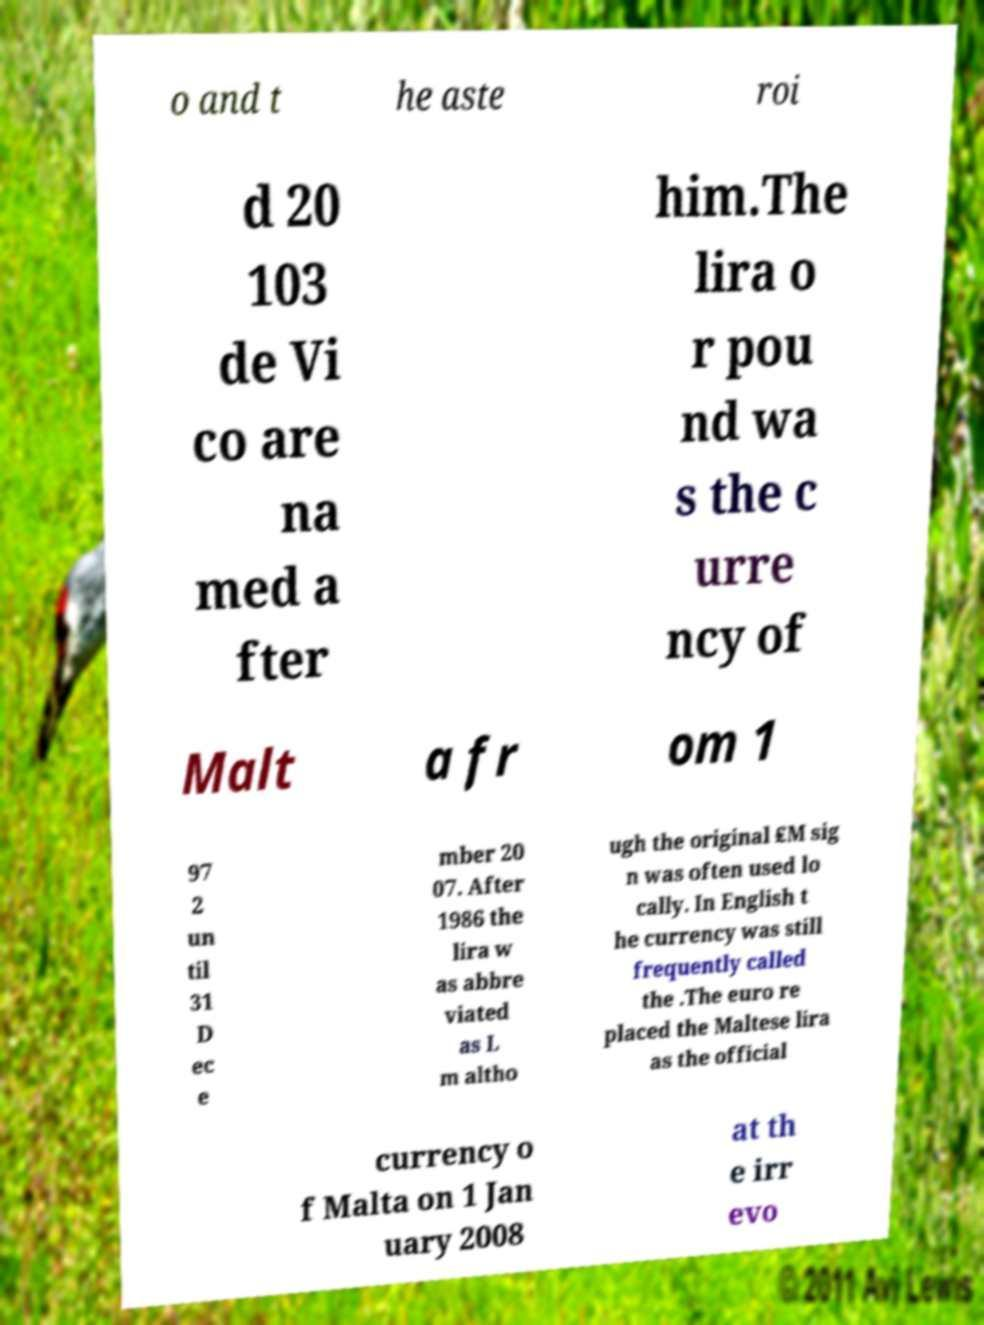For documentation purposes, I need the text within this image transcribed. Could you provide that? o and t he aste roi d 20 103 de Vi co are na med a fter him.The lira o r pou nd wa s the c urre ncy of Malt a fr om 1 97 2 un til 31 D ec e mber 20 07. After 1986 the lira w as abbre viated as L m altho ugh the original ₤M sig n was often used lo cally. In English t he currency was still frequently called the .The euro re placed the Maltese lira as the official currency o f Malta on 1 Jan uary 2008 at th e irr evo 